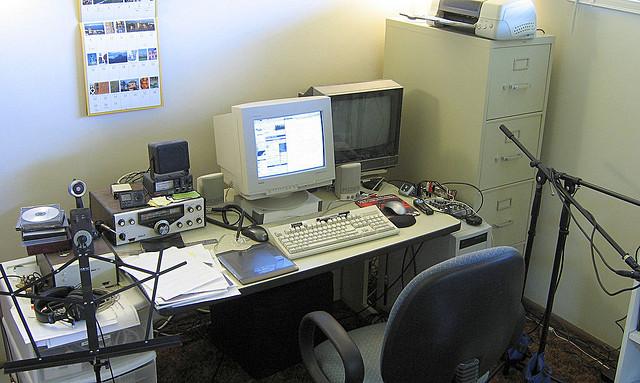Is the monitor on?
Give a very brief answer. Yes. Is there a image on the screen?
Keep it brief. Yes. Where is this?
Write a very short answer. Office. 